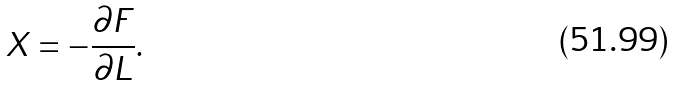<formula> <loc_0><loc_0><loc_500><loc_500>X = - \frac { \partial { F } } { \partial L } .</formula> 